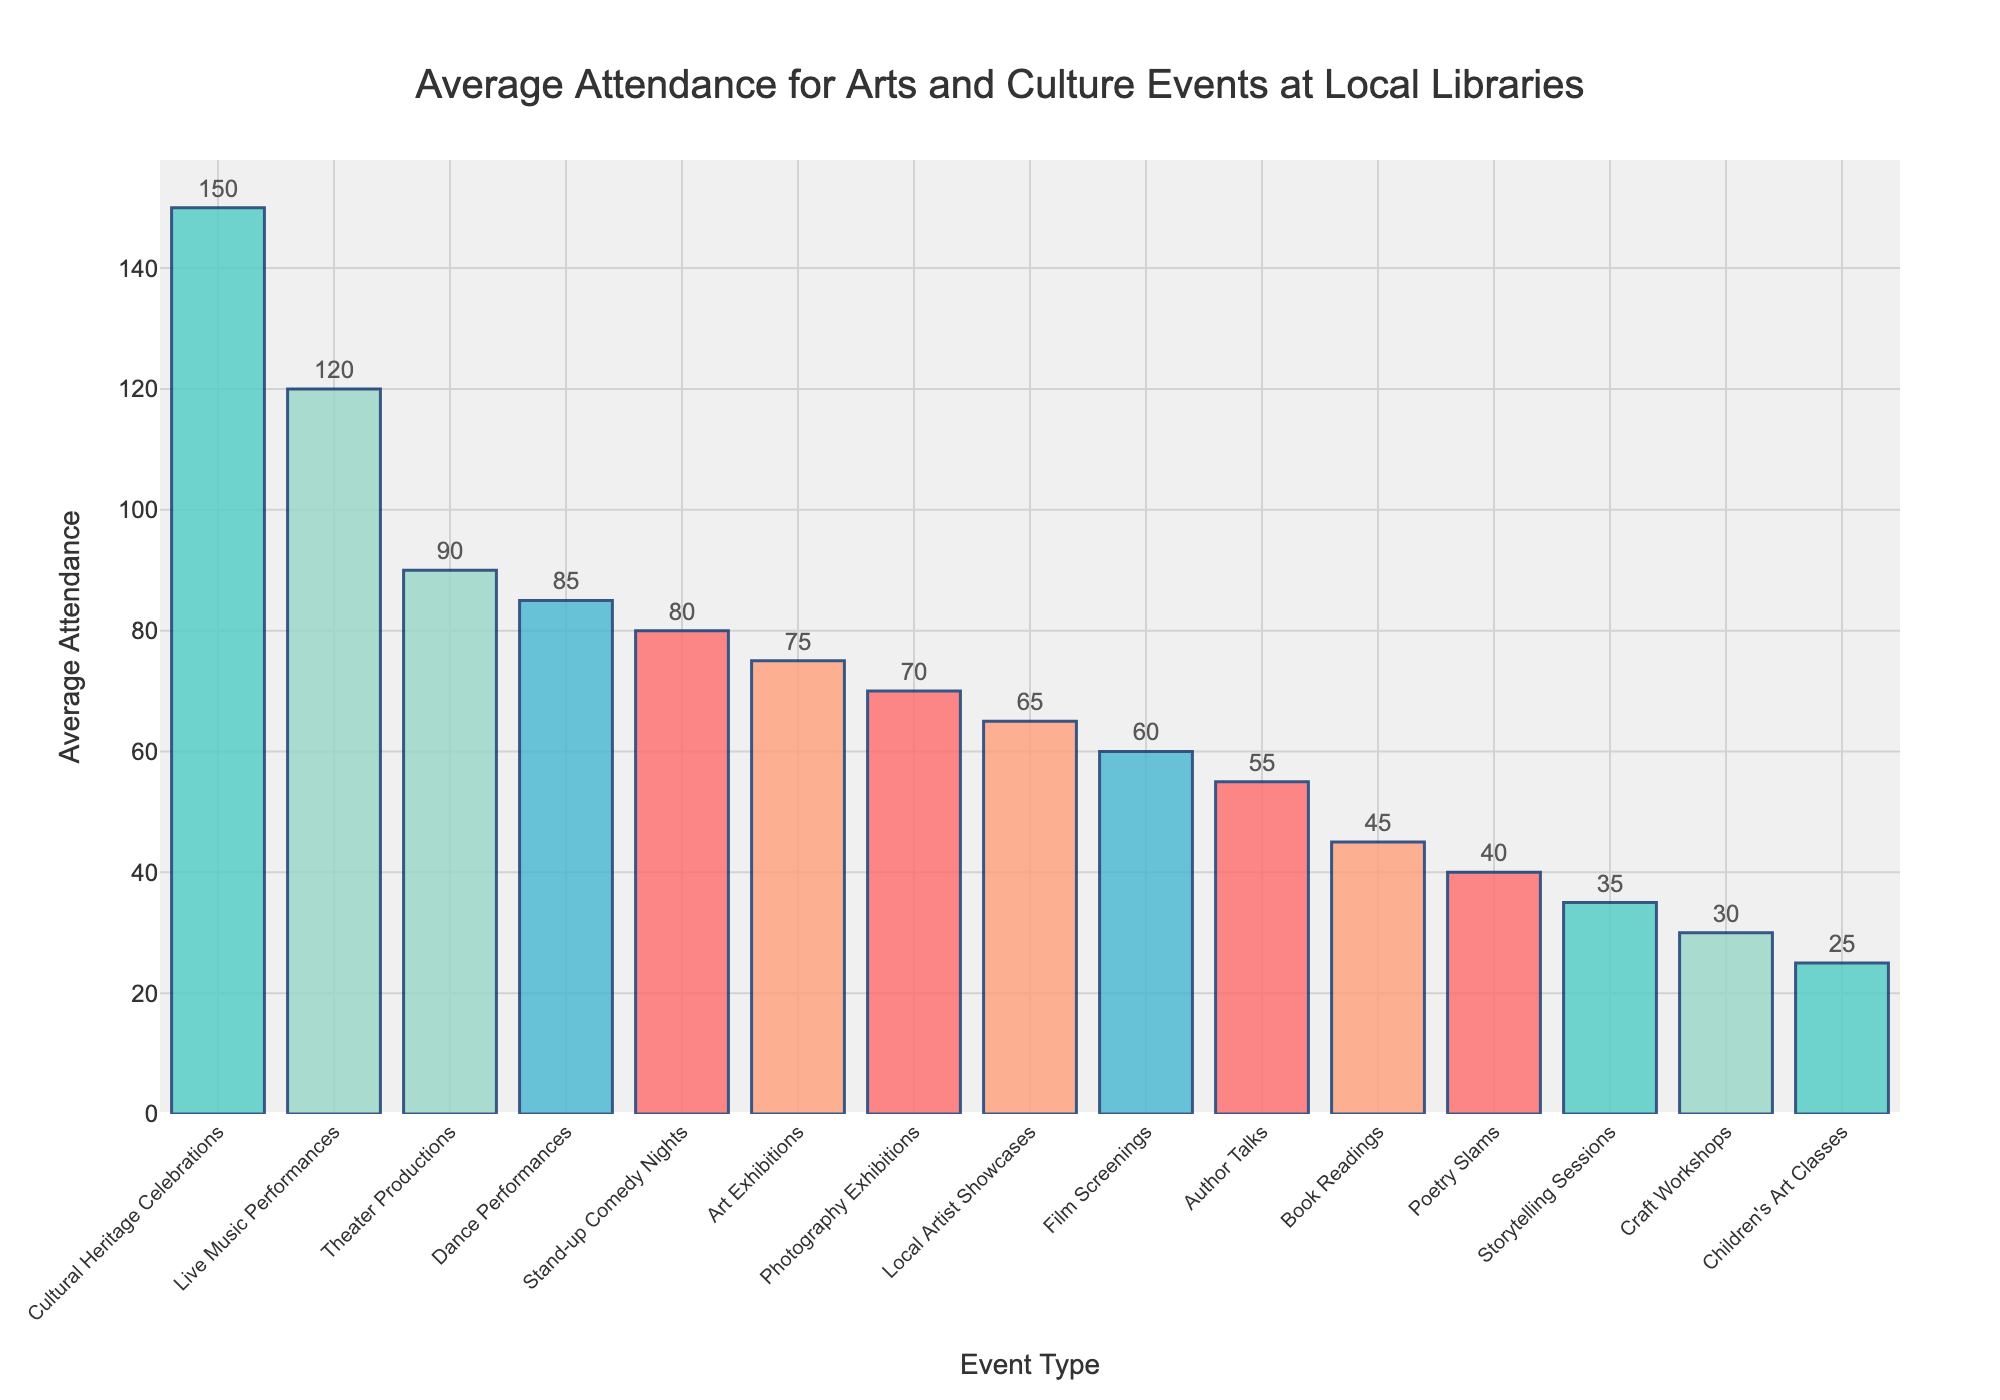What event type has the highest average attendance? We can see from the highest bar in the chart that Cultural Heritage Celebrations have the highest average attendance.
Answer: Cultural Heritage Celebrations What event type has the lowest average attendance? The shortest bar in the chart corresponds to Children's Art Classes, indicating it has the lowest average attendance.
Answer: Children's Art Classes How many event types have an average attendance of over 100? By examining the heights of the bars, we identify that Cultural Heritage Celebrations, Live Music Performances, and Theater Productions all have average attendances over 100, making a total of three event types.
Answer: 3 What is the difference in average attendance between Live Music Performances and Poetry Slams? The average attendance for Live Music Performances is 120 and for Poetry Slams is 40. Subtracting these values gives 120 - 40 = 80.
Answer: 80 How does the average attendance for Photography Exhibitions compare to that of Art Exhibitions? The bar for Art Exhibitions reaches 75, while the bar for Photography Exhibitions reaches 70. Since 75 is greater than 70, the average attendance for Art Exhibitions is higher.
Answer: Art Exhibitions are higher Which event has an average attendance closer to 50: Storytelling Sessions or Author Talks? Author Talks have an average attendance of 55, while Storytelling Sessions have 35. Since 55 is closer to 50 than 35, Author Talks have an average attendance closer to 50.
Answer: Author Talks What is the average attendance for the top three most attended events? The three most attended events are Cultural Heritage Celebrations (150), Live Music Performances (120), and Theater Productions (90). The average is calculated as (150 + 120 + 90) / 3 = 360 / 3 = 120.
Answer: 120 What is the sum of the average attendances for Book Readings, Film Screenings, and Craft Workshops? Adding the average attendances of Book Readings (45), Film Screenings (60), and Craft Workshops (30) gives 45 + 60 + 30 = 135.
Answer: 135 How does the average attendance for Stand-up Comedy Nights compare visually to that of Dance Performances? The bar for Stand-up Comedy Nights is slightly shorter than that for Dance Performances. This means that the average attendance for Stand-up Comedy Nights (80) is slightly lower than that of Dance Performances (85).
Answer: Dance Performances are higher 